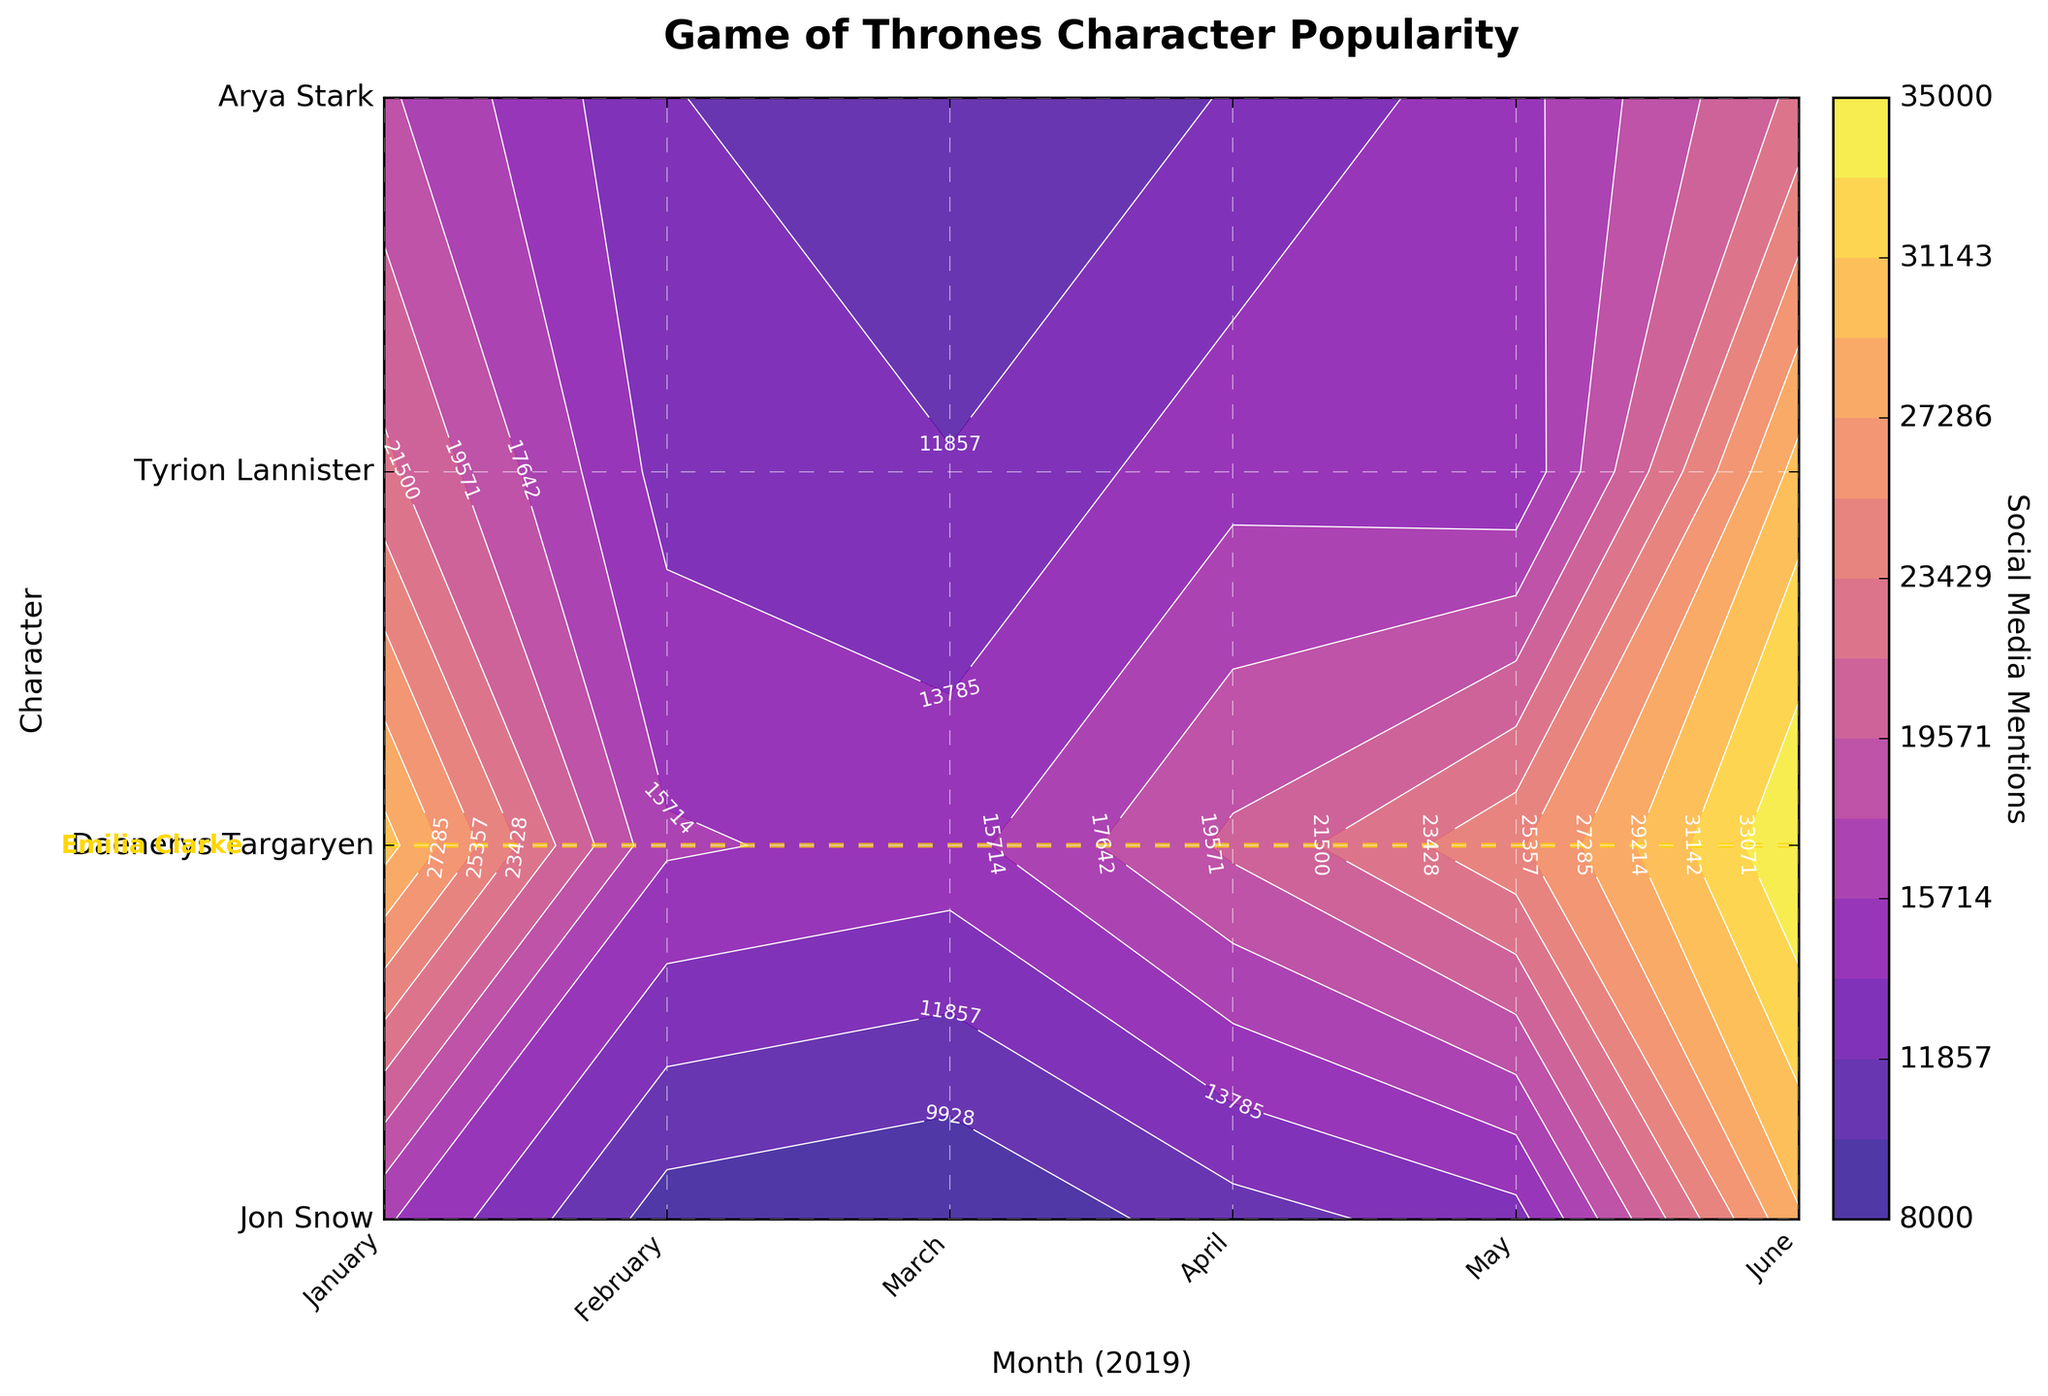What's the title of the figure? Check the text at the top center of the figure, which provides a high-level description.
Answer: Game of Thrones Character Popularity Which character had their popularity highlighted with a special line? Look for a character whose position on the y-axis has an extra line of a distinct color crossing it.
Answer: Daenerys Targaryen In which month did Daenerys Targaryen see the highest number of social media mentions? Check the contour levels for Daenerys (indicated by the horizontal gold line) and identify the month (x-axis) that corresponds to the highest contour level for her.
Answer: May How many months of data are shown for each character? Count the number of tick marks or labels on the x-axis.
Answer: 6 Which character had the least social media mentions in January 2019? Find the January 2019 column and identify the character (y-axis) that corresponds to the lowest contour value in that column.
Answer: Arya Stark Compare the popularity of Jon Snow and Tyrion Lannister in April 2019. Which character had more mentions? Check the contour levels for Jon Snow and Tyrion Lannister in the April column and compare their values.
Answer: Jon Snow By how much did Arya Stark's social media mentions increase from February 2019 to May 2019? Identify Arya Stark's mentions for both February and May, then subtract February's value from May's.
Answer: 20,000 What is the average number of mentions Daenerys Targaryen received over the six months shown? Calculate the sum of mentions for Daenerys Targaryen over the six months and divide by six. (15000 + 16000 + 25000 + 30000 + 35000 + 20000) / 6 = 23500
Answer: 23,500 Which month saw the overall highest level of social media mentions for all characters combined? Sum the contour levels for all characters in each month and identify the month with the highest total.
Answer: May 